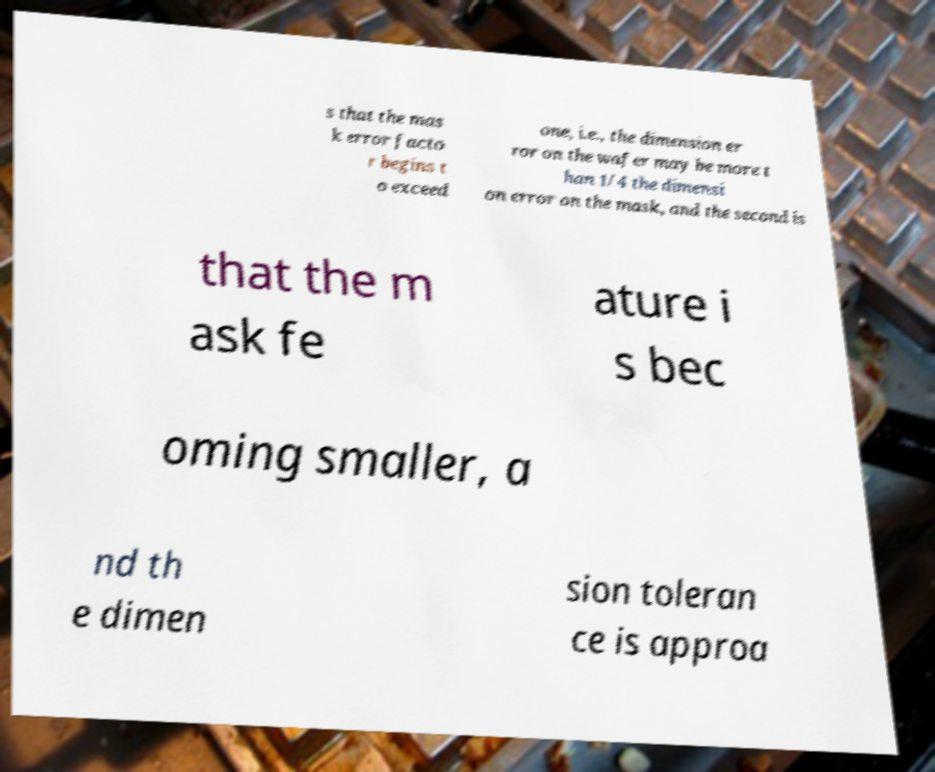There's text embedded in this image that I need extracted. Can you transcribe it verbatim? s that the mas k error facto r begins t o exceed one, i.e., the dimension er ror on the wafer may be more t han 1/4 the dimensi on error on the mask, and the second is that the m ask fe ature i s bec oming smaller, a nd th e dimen sion toleran ce is approa 